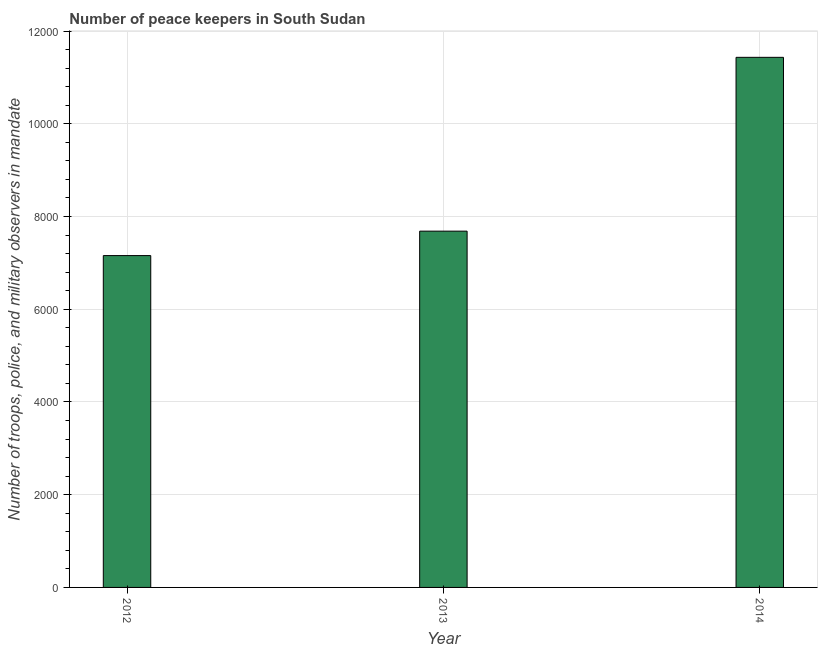What is the title of the graph?
Keep it short and to the point. Number of peace keepers in South Sudan. What is the label or title of the X-axis?
Provide a short and direct response. Year. What is the label or title of the Y-axis?
Your response must be concise. Number of troops, police, and military observers in mandate. What is the number of peace keepers in 2012?
Keep it short and to the point. 7157. Across all years, what is the maximum number of peace keepers?
Keep it short and to the point. 1.14e+04. Across all years, what is the minimum number of peace keepers?
Offer a very short reply. 7157. In which year was the number of peace keepers maximum?
Keep it short and to the point. 2014. In which year was the number of peace keepers minimum?
Keep it short and to the point. 2012. What is the sum of the number of peace keepers?
Ensure brevity in your answer.  2.63e+04. What is the difference between the number of peace keepers in 2013 and 2014?
Provide a succinct answer. -3749. What is the average number of peace keepers per year?
Your answer should be very brief. 8758. What is the median number of peace keepers?
Keep it short and to the point. 7684. Do a majority of the years between 2013 and 2012 (inclusive) have number of peace keepers greater than 1600 ?
Make the answer very short. No. What is the ratio of the number of peace keepers in 2013 to that in 2014?
Your response must be concise. 0.67. What is the difference between the highest and the second highest number of peace keepers?
Keep it short and to the point. 3749. What is the difference between the highest and the lowest number of peace keepers?
Offer a very short reply. 4276. In how many years, is the number of peace keepers greater than the average number of peace keepers taken over all years?
Ensure brevity in your answer.  1. How many years are there in the graph?
Provide a short and direct response. 3. What is the difference between two consecutive major ticks on the Y-axis?
Provide a succinct answer. 2000. Are the values on the major ticks of Y-axis written in scientific E-notation?
Make the answer very short. No. What is the Number of troops, police, and military observers in mandate in 2012?
Make the answer very short. 7157. What is the Number of troops, police, and military observers in mandate in 2013?
Make the answer very short. 7684. What is the Number of troops, police, and military observers in mandate in 2014?
Offer a terse response. 1.14e+04. What is the difference between the Number of troops, police, and military observers in mandate in 2012 and 2013?
Make the answer very short. -527. What is the difference between the Number of troops, police, and military observers in mandate in 2012 and 2014?
Provide a succinct answer. -4276. What is the difference between the Number of troops, police, and military observers in mandate in 2013 and 2014?
Offer a very short reply. -3749. What is the ratio of the Number of troops, police, and military observers in mandate in 2012 to that in 2013?
Offer a terse response. 0.93. What is the ratio of the Number of troops, police, and military observers in mandate in 2012 to that in 2014?
Provide a short and direct response. 0.63. What is the ratio of the Number of troops, police, and military observers in mandate in 2013 to that in 2014?
Ensure brevity in your answer.  0.67. 